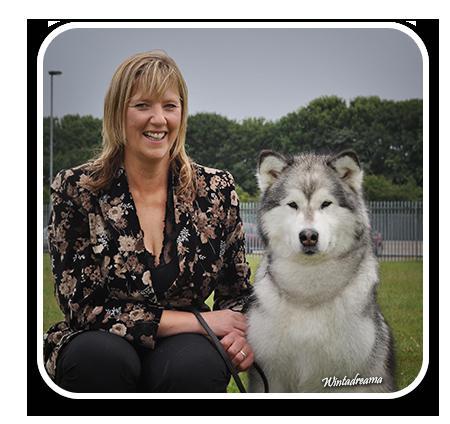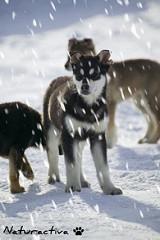The first image is the image on the left, the second image is the image on the right. Analyze the images presented: Is the assertion "The dogs in the image on the left are out in the snow." valid? Answer yes or no. No. The first image is the image on the left, the second image is the image on the right. Considering the images on both sides, is "In one of the images, a sitting dog and a single human are visible." valid? Answer yes or no. Yes. 